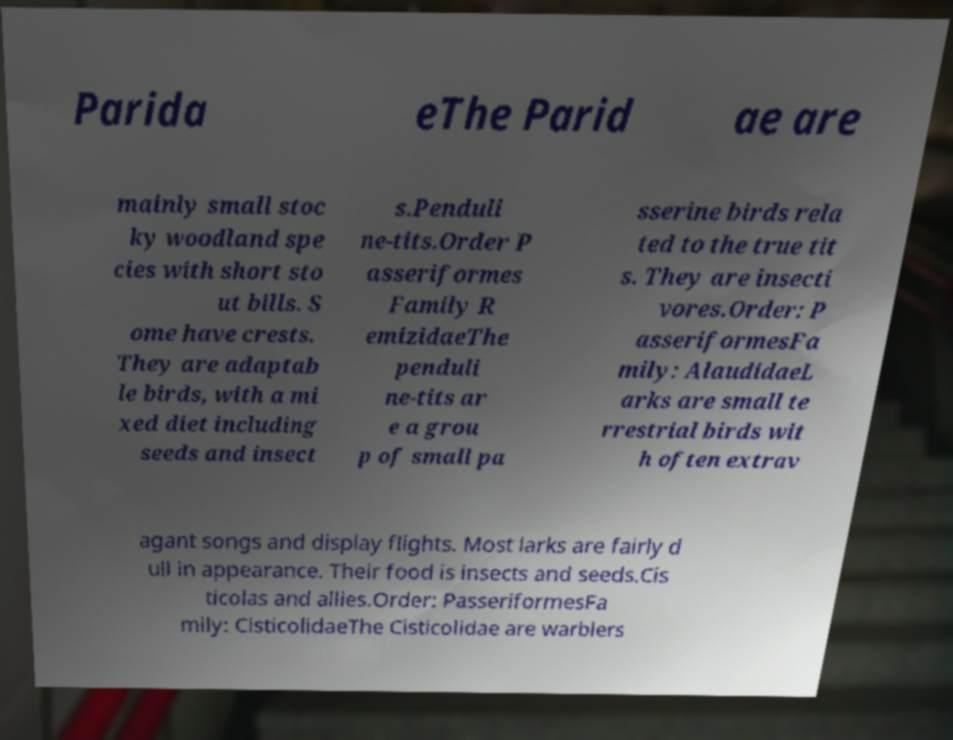There's text embedded in this image that I need extracted. Can you transcribe it verbatim? Parida eThe Parid ae are mainly small stoc ky woodland spe cies with short sto ut bills. S ome have crests. They are adaptab le birds, with a mi xed diet including seeds and insect s.Penduli ne-tits.Order P asseriformes Family R emizidaeThe penduli ne-tits ar e a grou p of small pa sserine birds rela ted to the true tit s. They are insecti vores.Order: P asseriformesFa mily: AlaudidaeL arks are small te rrestrial birds wit h often extrav agant songs and display flights. Most larks are fairly d ull in appearance. Their food is insects and seeds.Cis ticolas and allies.Order: PasseriformesFa mily: CisticolidaeThe Cisticolidae are warblers 